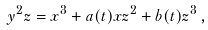<formula> <loc_0><loc_0><loc_500><loc_500>y ^ { 2 } z = x ^ { 3 } + a ( t ) x z ^ { 2 } + b ( t ) z ^ { 3 } \, ,</formula> 